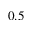<formula> <loc_0><loc_0><loc_500><loc_500>0 . 5</formula> 